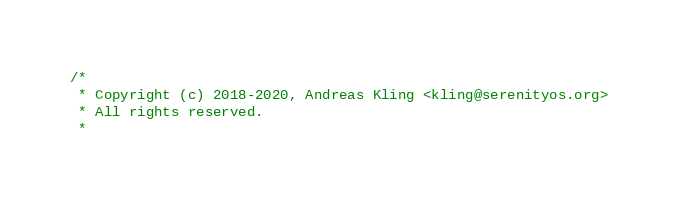Convert code to text. <code><loc_0><loc_0><loc_500><loc_500><_C_>/*
 * Copyright (c) 2018-2020, Andreas Kling <kling@serenityos.org>
 * All rights reserved.
 *</code> 